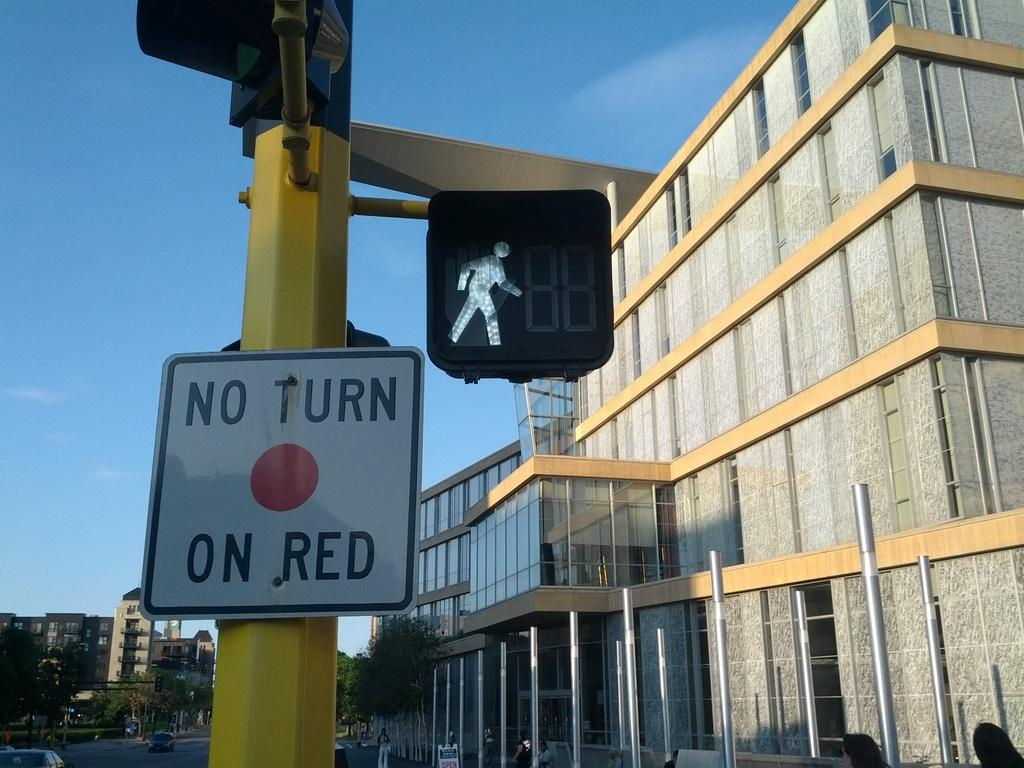Provide a one-sentence caption for the provided image. A walk sign is lit up next to a No Turn on Red sign. 